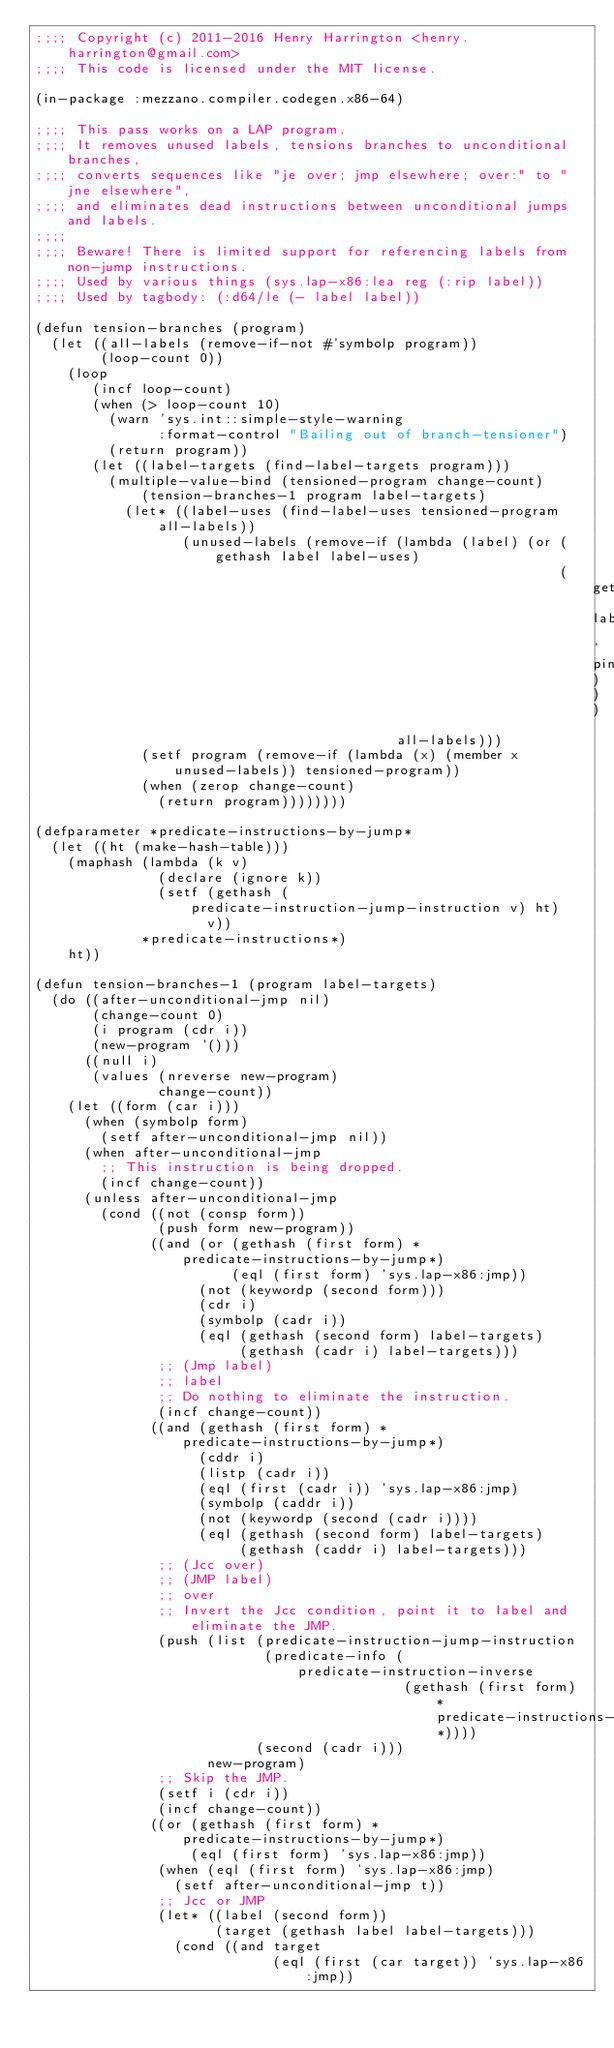<code> <loc_0><loc_0><loc_500><loc_500><_Lisp_>;;;; Copyright (c) 2011-2016 Henry Harrington <henry.harrington@gmail.com>
;;;; This code is licensed under the MIT license.

(in-package :mezzano.compiler.codegen.x86-64)

;;;; This pass works on a LAP program.
;;;; It removes unused labels, tensions branches to unconditional branches,
;;;; converts sequences like "je over; jmp elsewhere; over:" to "jne elsewhere",
;;;; and eliminates dead instructions between unconditional jumps and labels.
;;;;
;;;; Beware! There is limited support for referencing labels from non-jump instructions.
;;;; Used by various things (sys.lap-x86:lea reg (:rip label))
;;;; Used by tagbody: (:d64/le (- label label))

(defun tension-branches (program)
  (let ((all-labels (remove-if-not #'symbolp program))
        (loop-count 0))
    (loop
       (incf loop-count)
       (when (> loop-count 10)
         (warn 'sys.int::simple-style-warning
               :format-control "Bailing out of branch-tensioner")
         (return program))
       (let ((label-targets (find-label-targets program)))
         (multiple-value-bind (tensioned-program change-count)
             (tension-branches-1 program label-targets)
           (let* ((label-uses (find-label-uses tensioned-program all-labels))
                  (unused-labels (remove-if (lambda (label) (or (gethash label label-uses)
                                                                (get label 'pinned-label)))
                                            all-labels)))
             (setf program (remove-if (lambda (x) (member x unused-labels)) tensioned-program))
             (when (zerop change-count)
               (return program))))))))

(defparameter *predicate-instructions-by-jump*
  (let ((ht (make-hash-table)))
    (maphash (lambda (k v)
               (declare (ignore k))
               (setf (gethash (predicate-instruction-jump-instruction v) ht)
                     v))
             *predicate-instructions*)
    ht))

(defun tension-branches-1 (program label-targets)
  (do ((after-unconditional-jmp nil)
       (change-count 0)
       (i program (cdr i))
       (new-program '()))
      ((null i)
       (values (nreverse new-program)
               change-count))
    (let ((form (car i)))
      (when (symbolp form)
        (setf after-unconditional-jmp nil))
      (when after-unconditional-jmp
        ;; This instruction is being dropped.
        (incf change-count))
      (unless after-unconditional-jmp
        (cond ((not (consp form))
               (push form new-program))
              ((and (or (gethash (first form) *predicate-instructions-by-jump*)
                        (eql (first form) 'sys.lap-x86:jmp))
                    (not (keywordp (second form)))
                    (cdr i)
                    (symbolp (cadr i))
                    (eql (gethash (second form) label-targets)
                         (gethash (cadr i) label-targets)))
               ;; (Jmp label)
               ;; label
               ;; Do nothing to eliminate the instruction.
               (incf change-count))
              ((and (gethash (first form) *predicate-instructions-by-jump*)
                    (cddr i)
                    (listp (cadr i))
                    (eql (first (cadr i)) 'sys.lap-x86:jmp)
                    (symbolp (caddr i))
                    (not (keywordp (second (cadr i))))
                    (eql (gethash (second form) label-targets)
                         (gethash (caddr i) label-targets)))
               ;; (Jcc over)
               ;; (JMP label)
               ;; over
               ;; Invert the Jcc condition, point it to label and eliminate the JMP.
               (push (list (predicate-instruction-jump-instruction
                            (predicate-info (predicate-instruction-inverse
                                             (gethash (first form) *predicate-instructions-by-jump*))))
                           (second (cadr i)))
                     new-program)
               ;; Skip the JMP.
               (setf i (cdr i))
               (incf change-count))
              ((or (gethash (first form) *predicate-instructions-by-jump*)
                   (eql (first form) 'sys.lap-x86:jmp))
               (when (eql (first form) 'sys.lap-x86:jmp)
                 (setf after-unconditional-jmp t))
               ;; Jcc or JMP
               (let* ((label (second form))
                      (target (gethash label label-targets)))
                 (cond ((and target
                             (eql (first (car target)) 'sys.lap-x86:jmp))</code> 